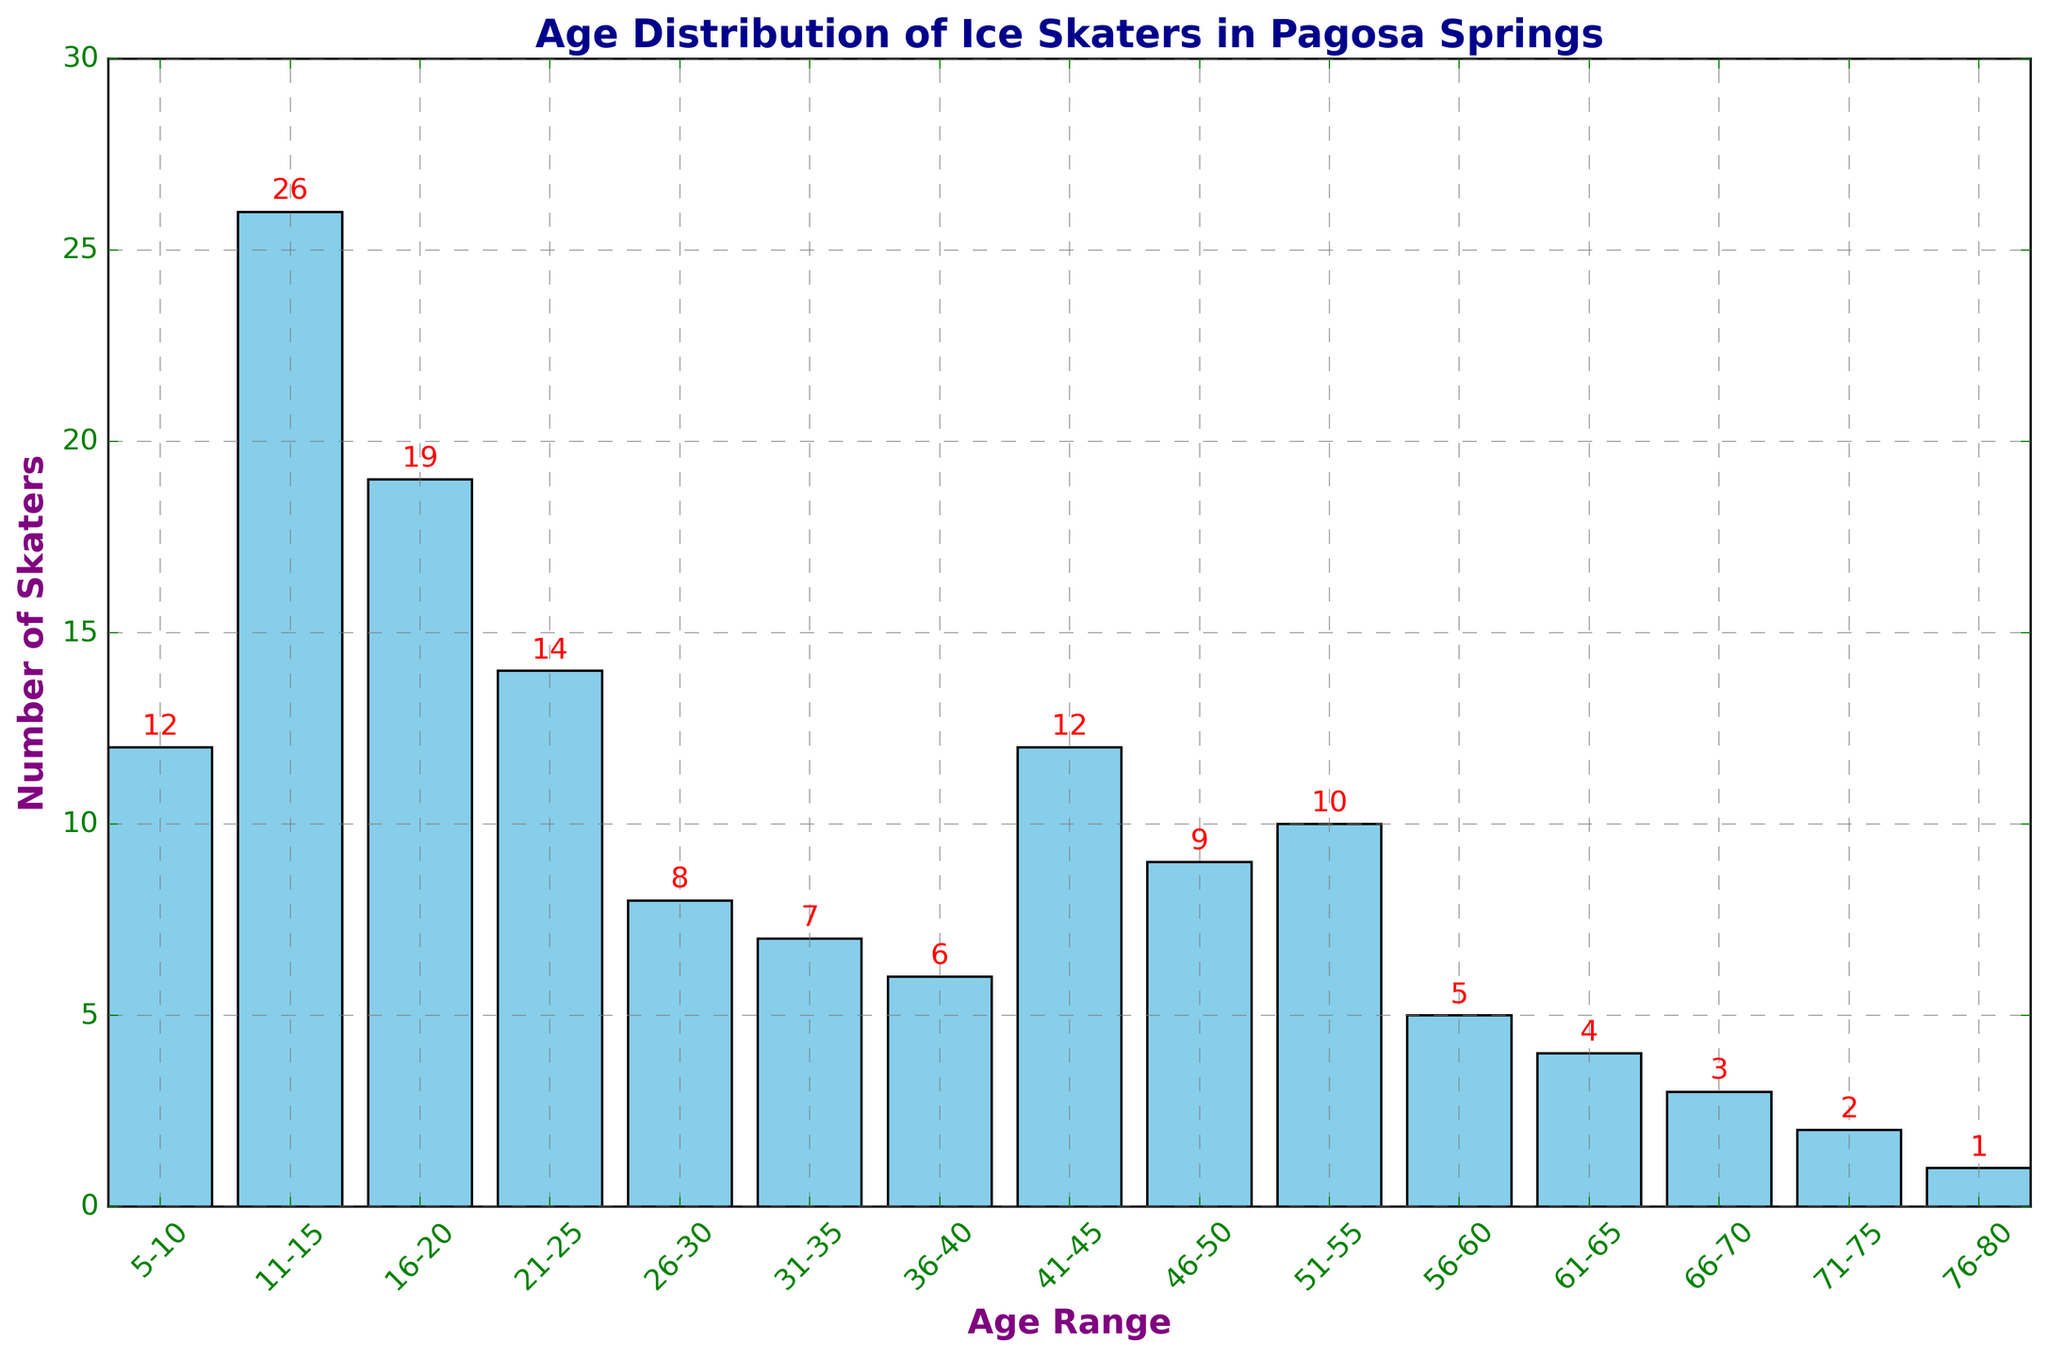Which age group has the highest number of ice skaters? By looking at the height of each bar, the tallest bar represents the age group with the highest number of ice skaters. The age group 11-15 has the tallest bar with 26 skaters.
Answer: 11-15 Which age groups have exactly 12 ice skaters? Identify the bars with a height labeled as '12'. The bars for age groups 5-10 and 41-45 both have a top label of '12'.
Answer: 5-10, 41-45 What is the total number of ice skaters aged 56-60 and 61-65? First, find the bar heights for the age groups 56-60 and 61-65. They are 5 and 4, respectively. Adding these together, 5 + 4 = 9.
Answer: 9 What is the difference in the number of ice skaters between the age groups 16-20 and 31-35? The bar heights for 16-20 and 31-35 are 19 and 7, respectively. The difference is 19 - 7 = 12.
Answer: 12 How many ice skaters are there in the age groups older than 60? Sum the heights of the bars for age groups 61-65, 66-70, 71-75, and 76-80. The counts are 4, 3, 2, and 1 respectively. So, 4 + 3 + 2 + 1 = 10.
Answer: 10 Which age range shows the least number of ice skaters? Identify the bar with the smallest height. The age group 76-80 has the shortest bar with only 1 skater.
Answer: 76-80 Compare the number of skaters in the 26-30 age group to the 46-50 age group. Which is higher? The bar for 26-30 is 8 skaters high, while the bar for 46-50 is 9 skaters high. Therefore, 46-50 has more skaters.
Answer: 46-50 What is the average number of skaters in the age groups 21-25, 26-30, and 31-35? The bar heights for the age groups 21-25, 26-30, and 31-35 are 14, 8, and 7, respectively. Sum these values: 14 + 8 + 7 = 29. There are 3 groups, so the average is 29/3 ≈ 9.67.
Answer: 9.67 How many ice skaters are under 20 years old? Sum the heights of the bars for age groups 5-10, 11-15, and 16-20. The counts are 12, 26, and 19, respectively. So, 12 + 26 + 19 = 57.
Answer: 57 